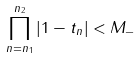Convert formula to latex. <formula><loc_0><loc_0><loc_500><loc_500>\prod _ { n = n _ { 1 } } ^ { n _ { 2 } } | 1 - t _ { n } | < M _ { - }</formula> 